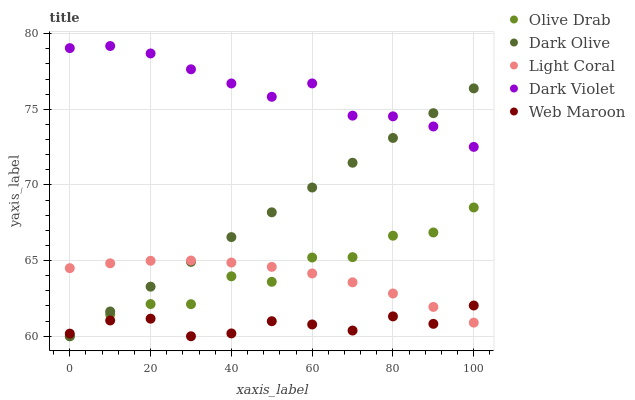Does Web Maroon have the minimum area under the curve?
Answer yes or no. Yes. Does Dark Violet have the maximum area under the curve?
Answer yes or no. Yes. Does Dark Olive have the minimum area under the curve?
Answer yes or no. No. Does Dark Olive have the maximum area under the curve?
Answer yes or no. No. Is Dark Olive the smoothest?
Answer yes or no. Yes. Is Olive Drab the roughest?
Answer yes or no. Yes. Is Web Maroon the smoothest?
Answer yes or no. No. Is Web Maroon the roughest?
Answer yes or no. No. Does Dark Olive have the lowest value?
Answer yes or no. Yes. Does Dark Violet have the lowest value?
Answer yes or no. No. Does Dark Violet have the highest value?
Answer yes or no. Yes. Does Dark Olive have the highest value?
Answer yes or no. No. Is Web Maroon less than Dark Violet?
Answer yes or no. Yes. Is Dark Violet greater than Web Maroon?
Answer yes or no. Yes. Does Dark Violet intersect Dark Olive?
Answer yes or no. Yes. Is Dark Violet less than Dark Olive?
Answer yes or no. No. Is Dark Violet greater than Dark Olive?
Answer yes or no. No. Does Web Maroon intersect Dark Violet?
Answer yes or no. No. 